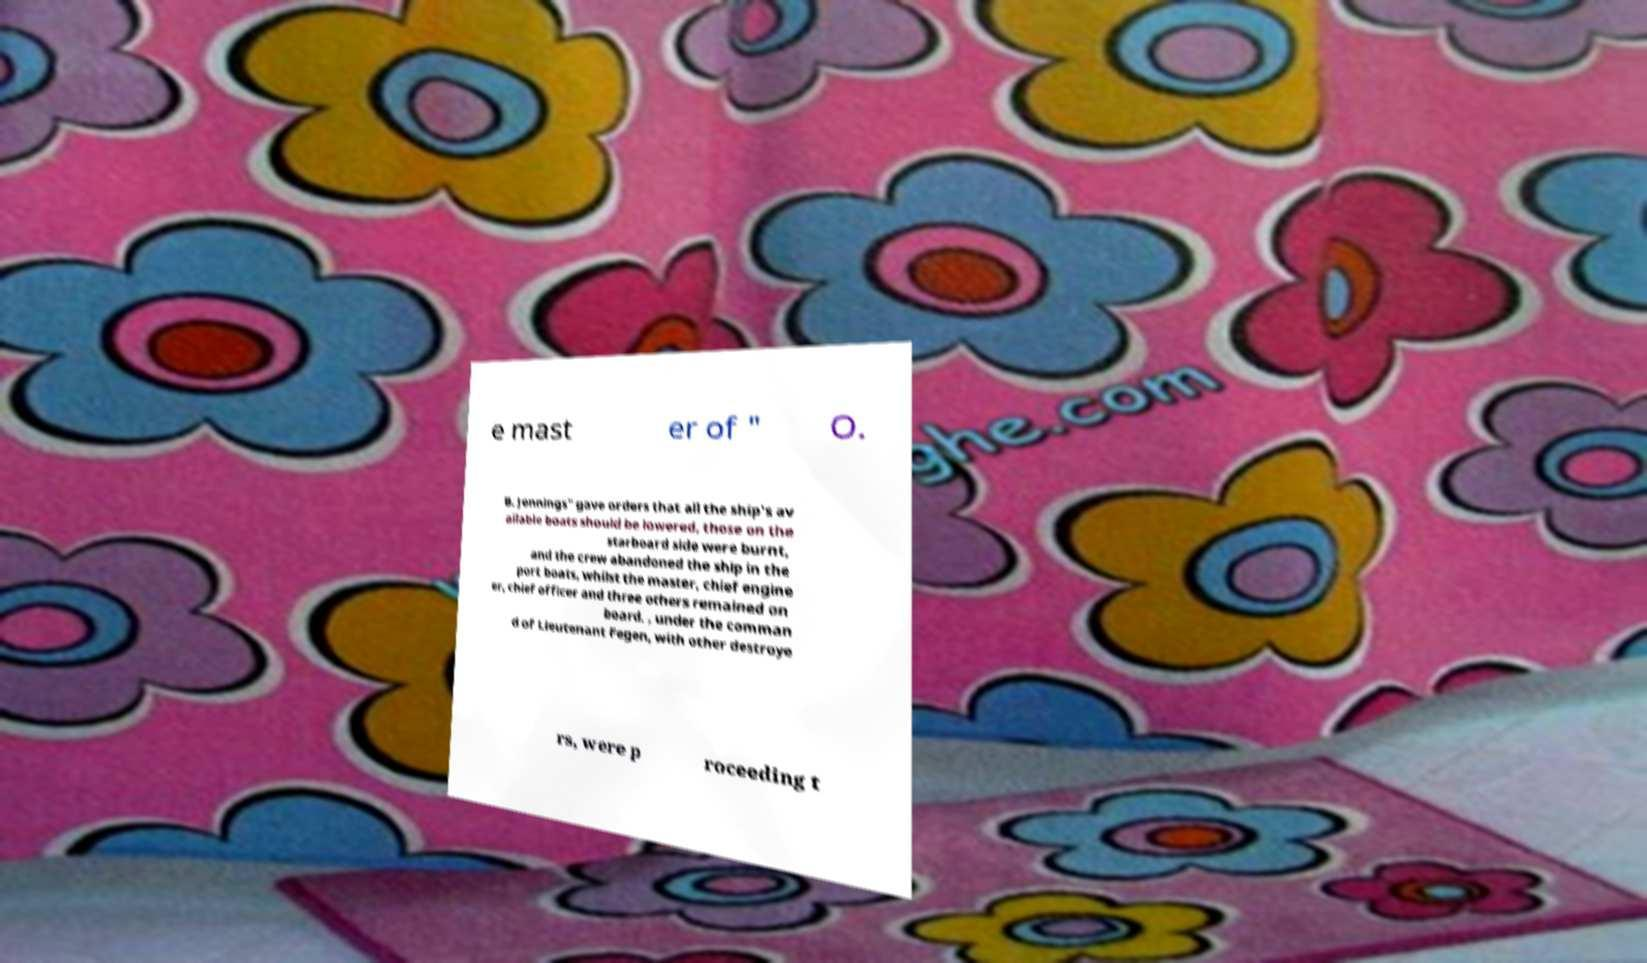For documentation purposes, I need the text within this image transcribed. Could you provide that? e mast er of " O. B. Jennings" gave orders that all the ship's av ailable boats should be lowered, those on the starboard side were burnt, and the crew abandoned the ship in the port boats, whilst the master, chief engine er, chief officer and three others remained on board. , under the comman d of Lieutenant Fegen, with other destroye rs, were p roceeding t 